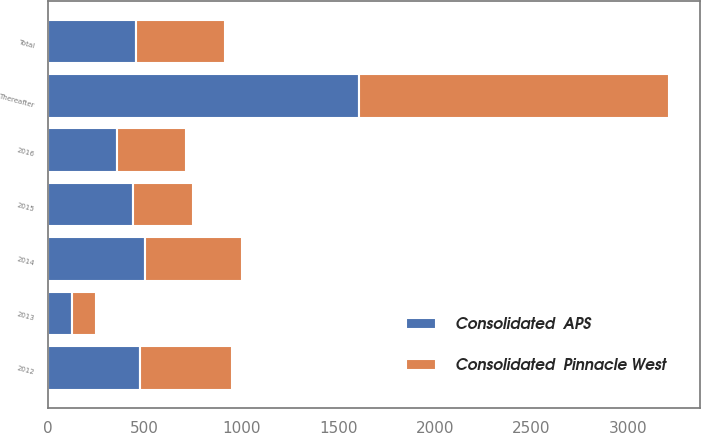<chart> <loc_0><loc_0><loc_500><loc_500><stacked_bar_chart><ecel><fcel>2012<fcel>2013<fcel>2014<fcel>2015<fcel>2016<fcel>Thereafter<fcel>Total<nl><fcel>Consolidated  APS<fcel>477<fcel>123<fcel>502<fcel>438<fcel>358<fcel>1606<fcel>457.5<nl><fcel>Consolidated  Pinnacle West<fcel>477<fcel>123<fcel>502<fcel>313<fcel>358<fcel>1606<fcel>457.5<nl></chart> 